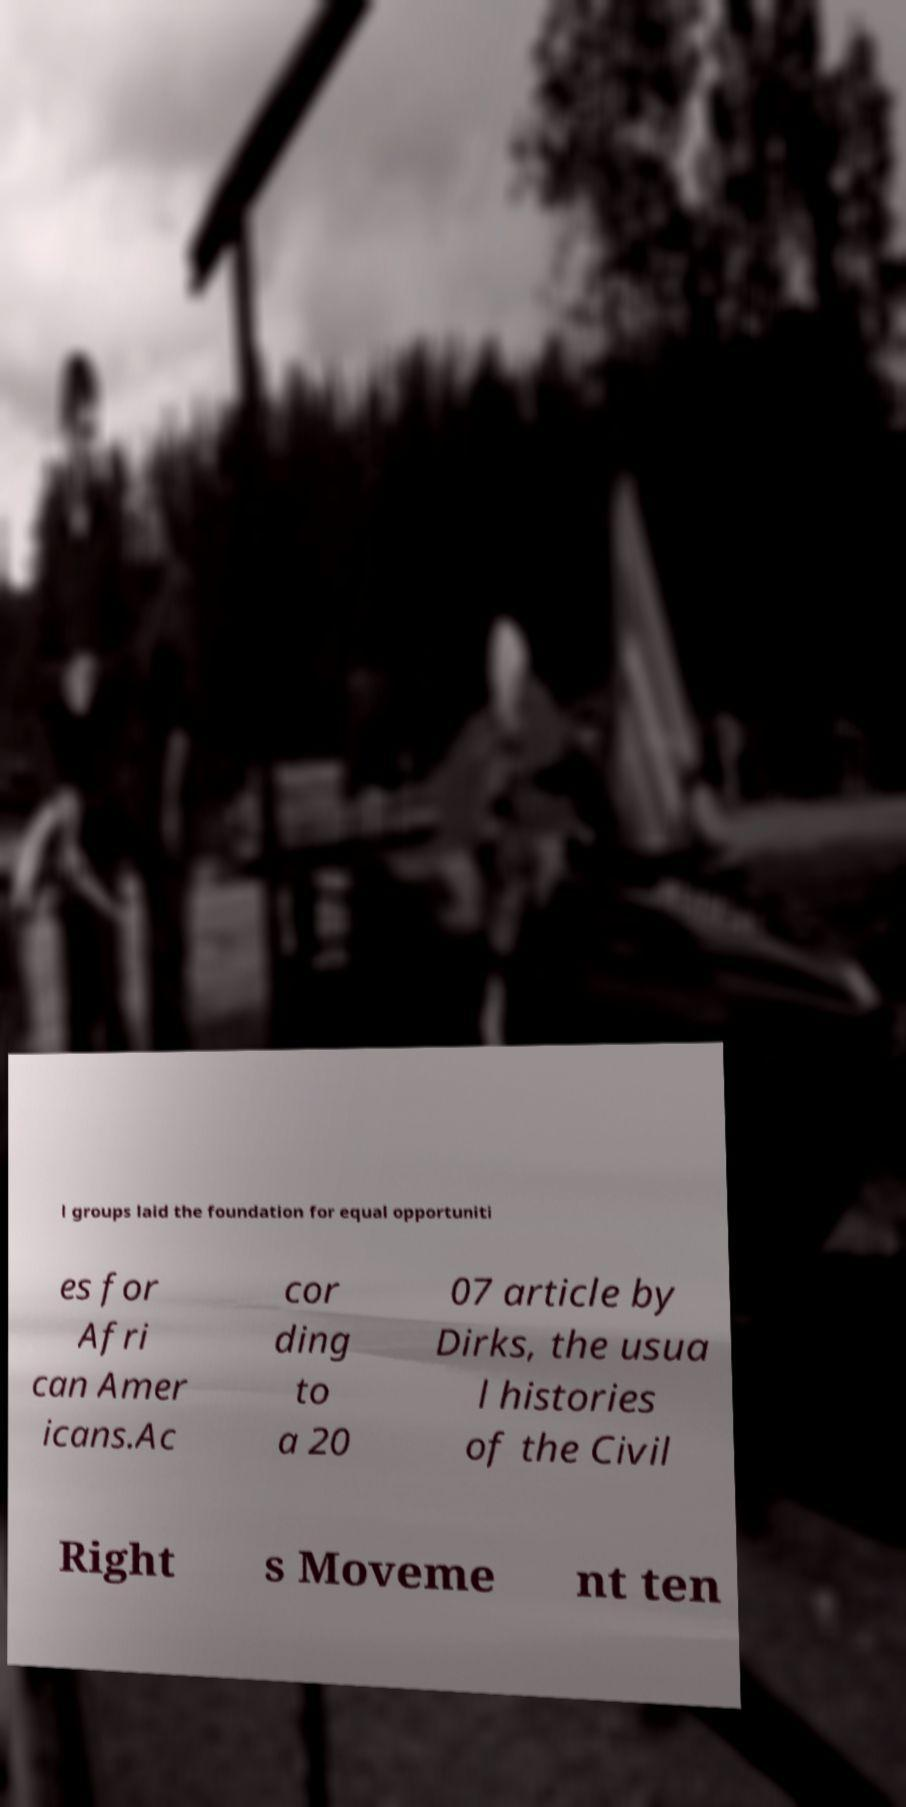There's text embedded in this image that I need extracted. Can you transcribe it verbatim? l groups laid the foundation for equal opportuniti es for Afri can Amer icans.Ac cor ding to a 20 07 article by Dirks, the usua l histories of the Civil Right s Moveme nt ten 